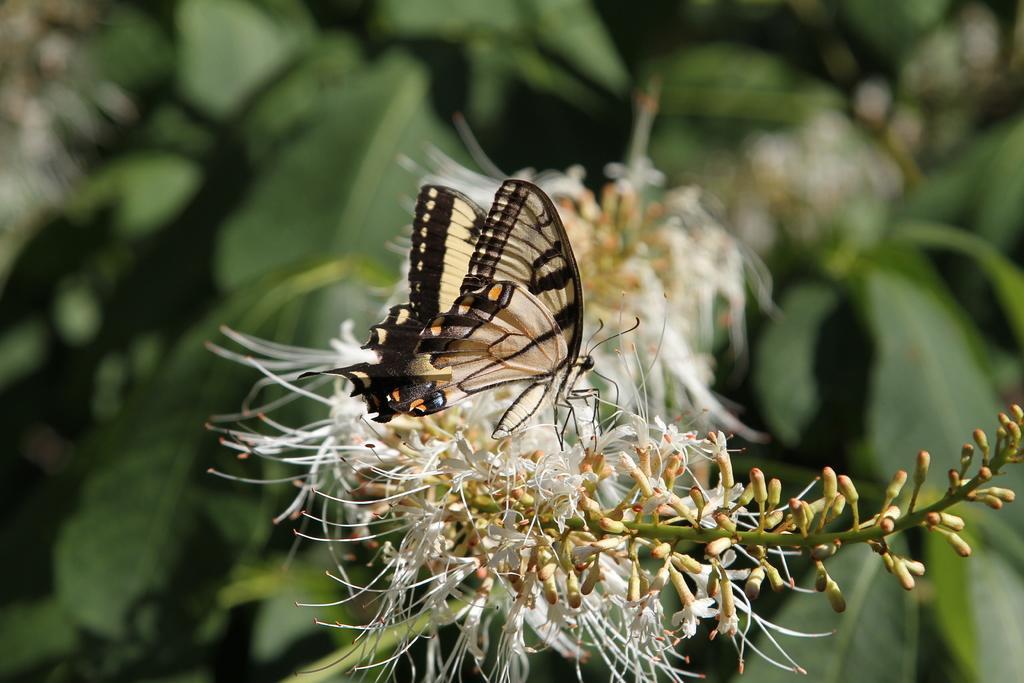Please provide a concise description of this image. In the center of the image we can see a butterfly on the flower. In the background there are leaves. 